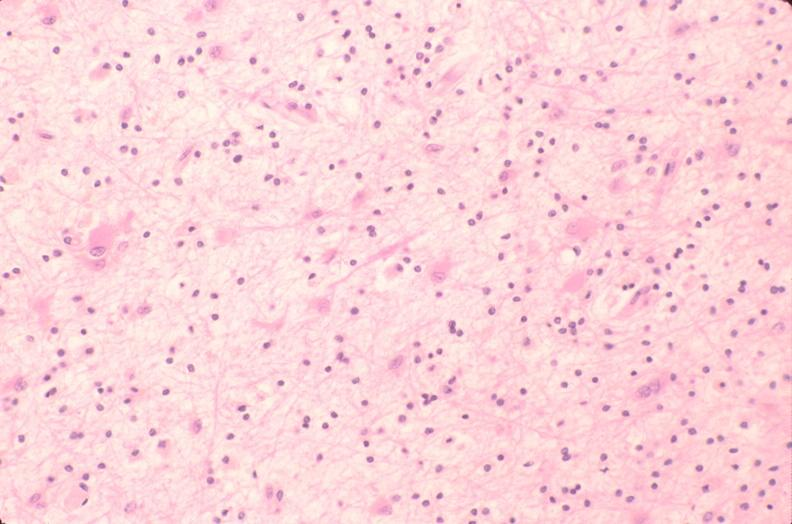does this image show brain, encephalomalasia?
Answer the question using a single word or phrase. Yes 